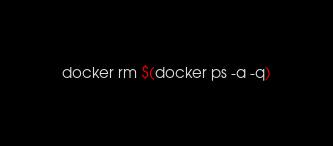<code> <loc_0><loc_0><loc_500><loc_500><_Bash_>docker rm $(docker ps -a -q)</code> 